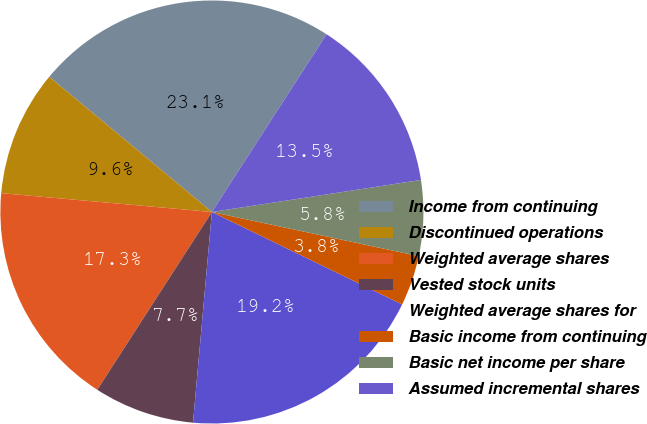Convert chart. <chart><loc_0><loc_0><loc_500><loc_500><pie_chart><fcel>Income from continuing<fcel>Discontinued operations<fcel>Weighted average shares<fcel>Vested stock units<fcel>Weighted average shares for<fcel>Basic income from continuing<fcel>Basic net income per share<fcel>Assumed incremental shares<nl><fcel>23.08%<fcel>9.62%<fcel>17.31%<fcel>7.69%<fcel>19.23%<fcel>3.85%<fcel>5.77%<fcel>13.46%<nl></chart> 